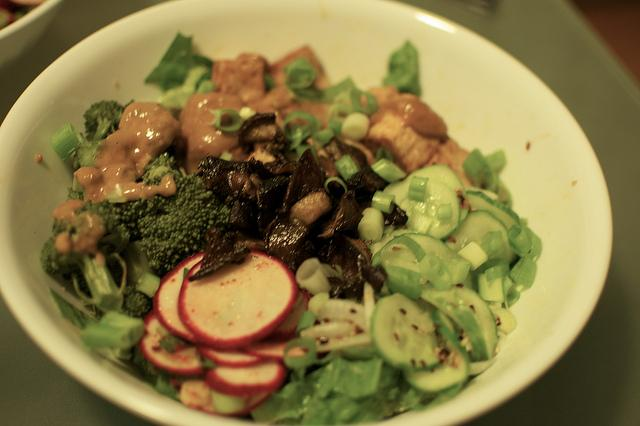What animal would most enjoy the food in the bowl? rabbit 